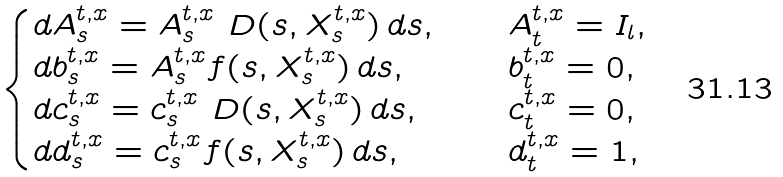<formula> <loc_0><loc_0><loc_500><loc_500>\begin{cases} d A _ { s } ^ { t , x } = A _ { s } ^ { t , x } \ D ( s , X _ { s } ^ { t , x } ) \, d s , & \quad A _ { t } ^ { t , x } = I _ { l } , \\ d b _ { s } ^ { t , x } = A _ { s } ^ { t , x } f ( s , X _ { s } ^ { t , x } ) \, d s , & \quad b _ { t } ^ { t , x } = 0 , \\ d c _ { s } ^ { t , x } = c _ { s } ^ { t , x } \ D ( s , X _ { s } ^ { t , x } ) \, d s , & \quad c _ { t } ^ { t , x } = 0 , \\ d d _ { s } ^ { t , x } = c _ { s } ^ { t , x } f ( s , X _ { s } ^ { t , x } ) \, d s , & \quad d _ { t } ^ { t , x } = 1 , \end{cases}</formula> 